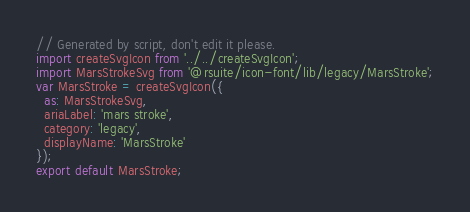Convert code to text. <code><loc_0><loc_0><loc_500><loc_500><_JavaScript_>// Generated by script, don't edit it please.
import createSvgIcon from '../../createSvgIcon';
import MarsStrokeSvg from '@rsuite/icon-font/lib/legacy/MarsStroke';
var MarsStroke = createSvgIcon({
  as: MarsStrokeSvg,
  ariaLabel: 'mars stroke',
  category: 'legacy',
  displayName: 'MarsStroke'
});
export default MarsStroke;</code> 